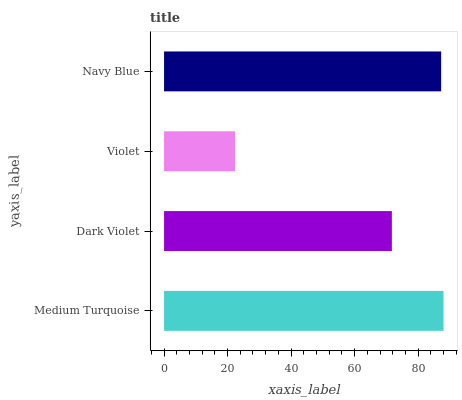Is Violet the minimum?
Answer yes or no. Yes. Is Medium Turquoise the maximum?
Answer yes or no. Yes. Is Dark Violet the minimum?
Answer yes or no. No. Is Dark Violet the maximum?
Answer yes or no. No. Is Medium Turquoise greater than Dark Violet?
Answer yes or no. Yes. Is Dark Violet less than Medium Turquoise?
Answer yes or no. Yes. Is Dark Violet greater than Medium Turquoise?
Answer yes or no. No. Is Medium Turquoise less than Dark Violet?
Answer yes or no. No. Is Navy Blue the high median?
Answer yes or no. Yes. Is Dark Violet the low median?
Answer yes or no. Yes. Is Dark Violet the high median?
Answer yes or no. No. Is Violet the low median?
Answer yes or no. No. 